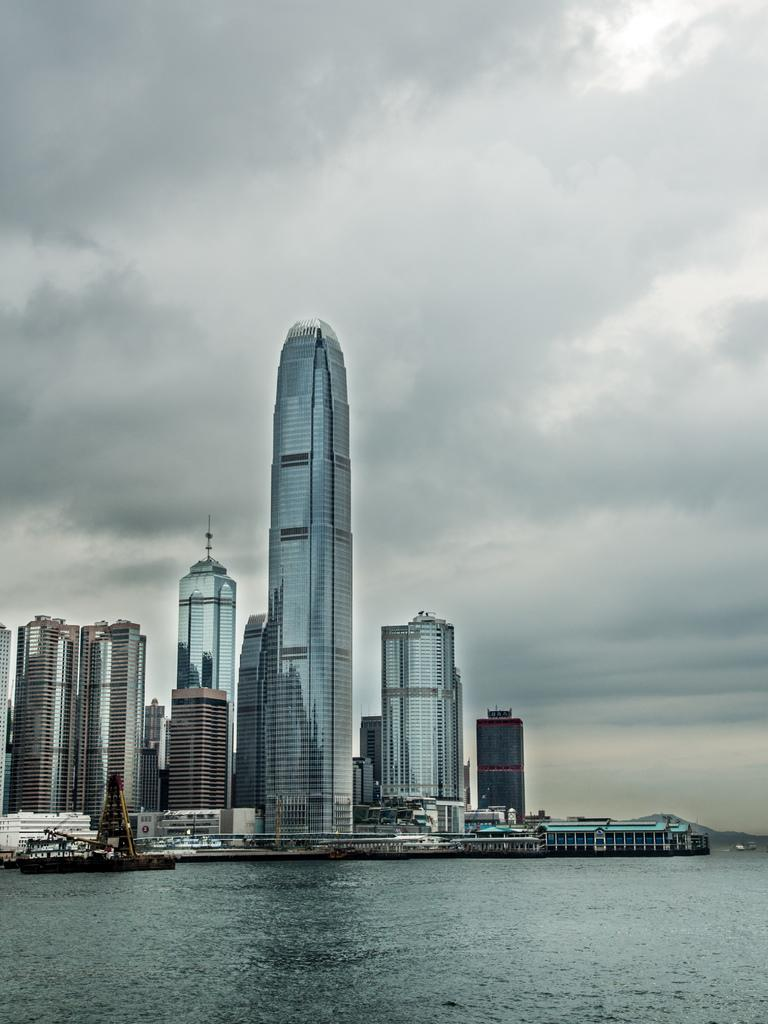What is the main setting of the image? There is a sea in the image. What unusual element can be seen in the sea? There are sheep in the sea. What can be seen in the distance in the image? There are buildings in the background of the image. How would you describe the weather in the image? The sky is cloudy in the background of the image. What type of hair can be seen on the sheep in the image? There is no hair visible on the sheep in the image, as they are likely covered in wool. 